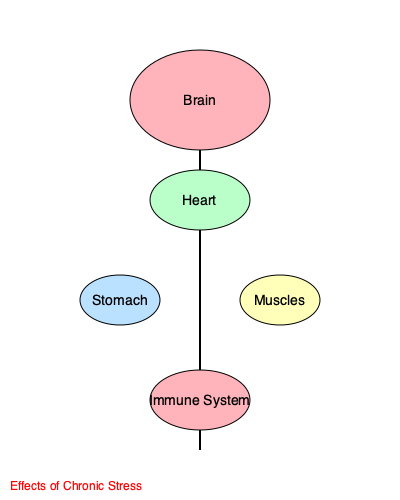In the context of coping with loss and grief, which system in the body is most likely to be compromised due to chronic stress, potentially leading to increased susceptibility to illness? 1. Chronic stress, such as that experienced during grief, affects multiple body systems:

   a) Brain: Can lead to anxiety, depression, and cognitive issues
   b) Heart: May cause increased blood pressure and heart rate
   c) Stomach: Can result in digestive problems
   d) Muscles: May cause tension and pain
   e) Immune System: Often becomes suppressed

2. While all systems are affected, the immune system is particularly vulnerable:

   a) Stress hormones like cortisol can suppress immune function
   b) This suppression reduces the body's ability to fight off infections and diseases

3. In the context of loss and grief:

   a) Prolonged emotional stress can lead to chronic elevation of stress hormones
   b) This constant elevation can significantly impair immune function over time

4. A compromised immune system:

   a) Increases susceptibility to various illnesses
   b) May lead to more frequent or severe infections
   c) Can potentially exacerbate existing health conditions

5. Therefore, while coping with loss, it's crucial to be aware of this potential health risk and take steps to support the immune system through self-care, proper nutrition, and stress management techniques.
Answer: Immune System 